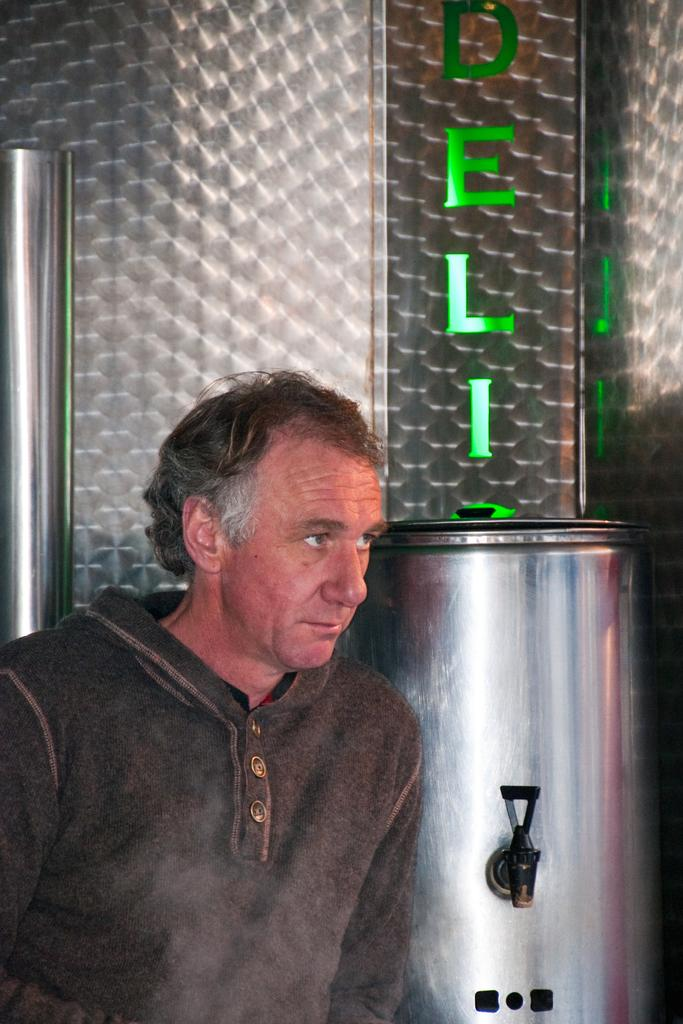Provide a one-sentence caption for the provided image. a man standing in front of a silver tank under a green sign that reads deli. 